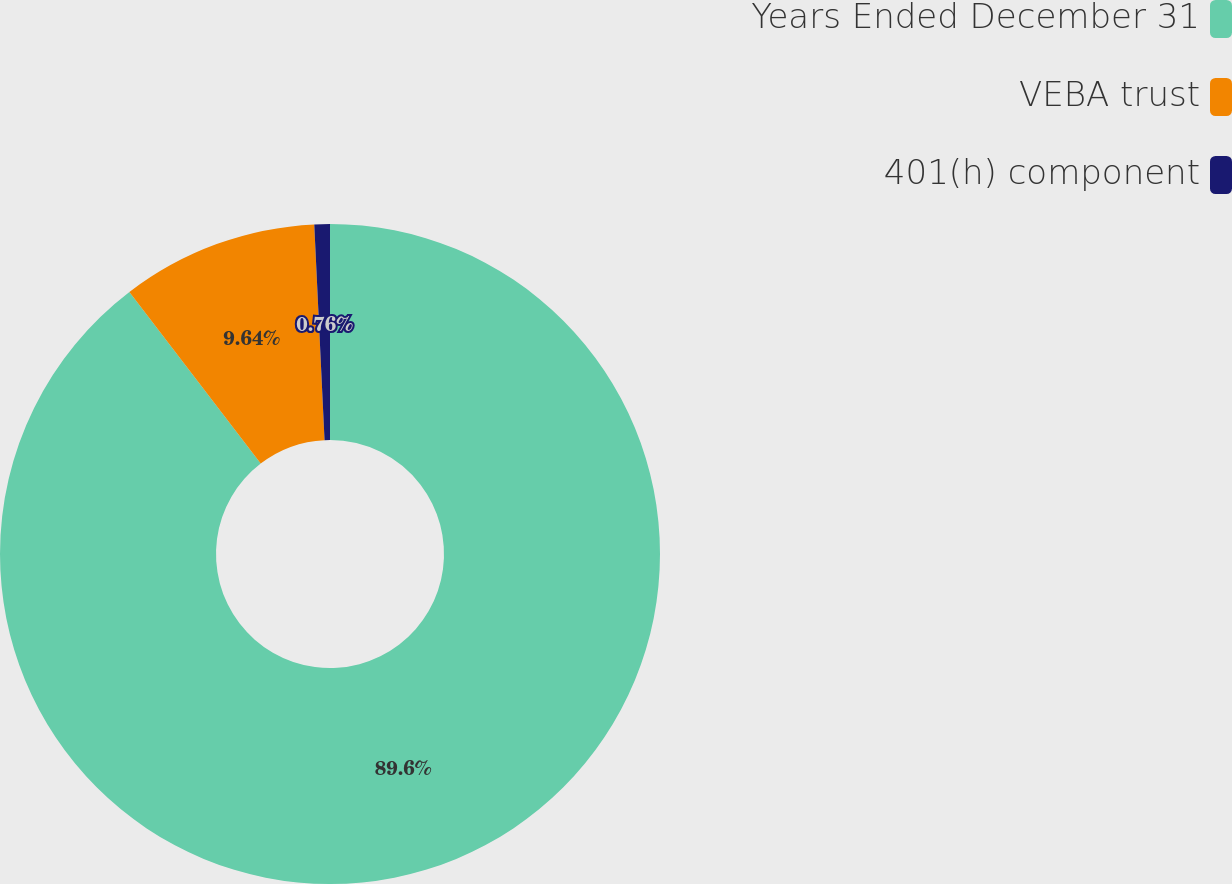Convert chart. <chart><loc_0><loc_0><loc_500><loc_500><pie_chart><fcel>Years Ended December 31<fcel>VEBA trust<fcel>401(h) component<nl><fcel>89.6%<fcel>9.64%<fcel>0.76%<nl></chart> 